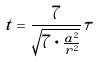<formula> <loc_0><loc_0><loc_500><loc_500>t = \frac { 7 } { \sqrt { 7 \cdot \frac { a ^ { 2 } } { r ^ { 2 } } } } \tau</formula> 